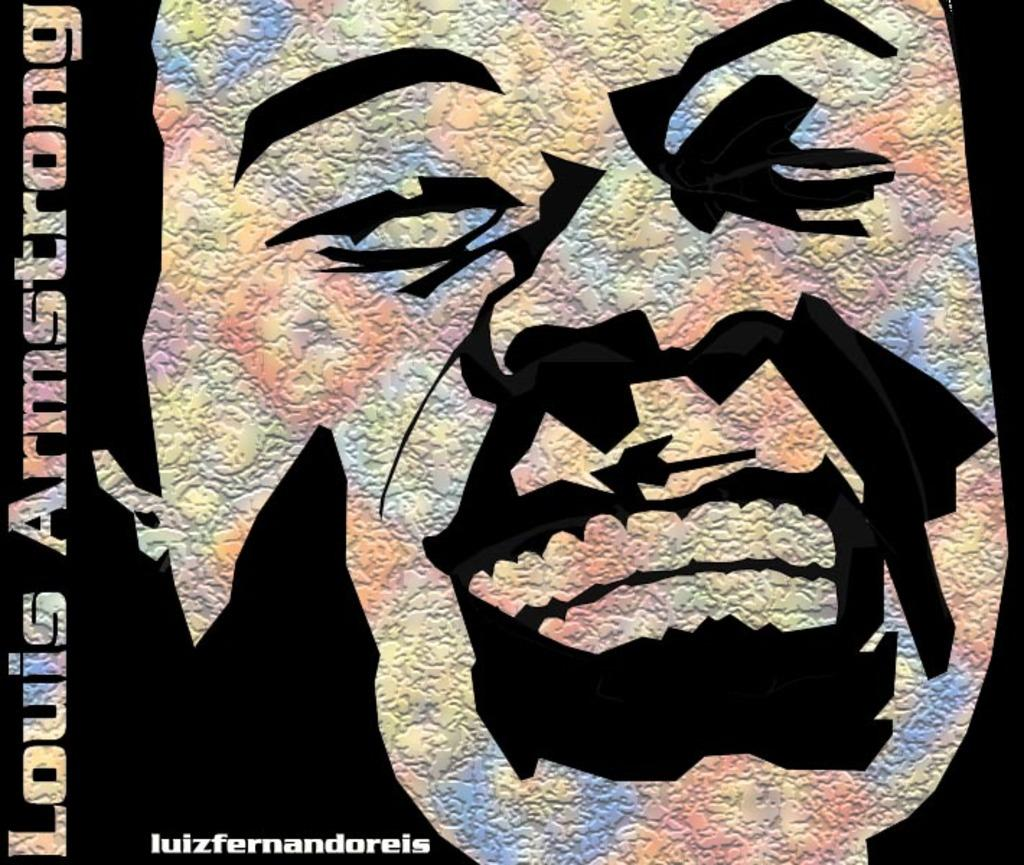What is the main subject of the image? The main subject of the image is a depiction of a person's face. Where can text be found in the image? There is text written on the left side of the image and on the bottom left side of the image. What type of breakfast is being served in the image? There is no breakfast depicted in the image; it features a person's face and text. 